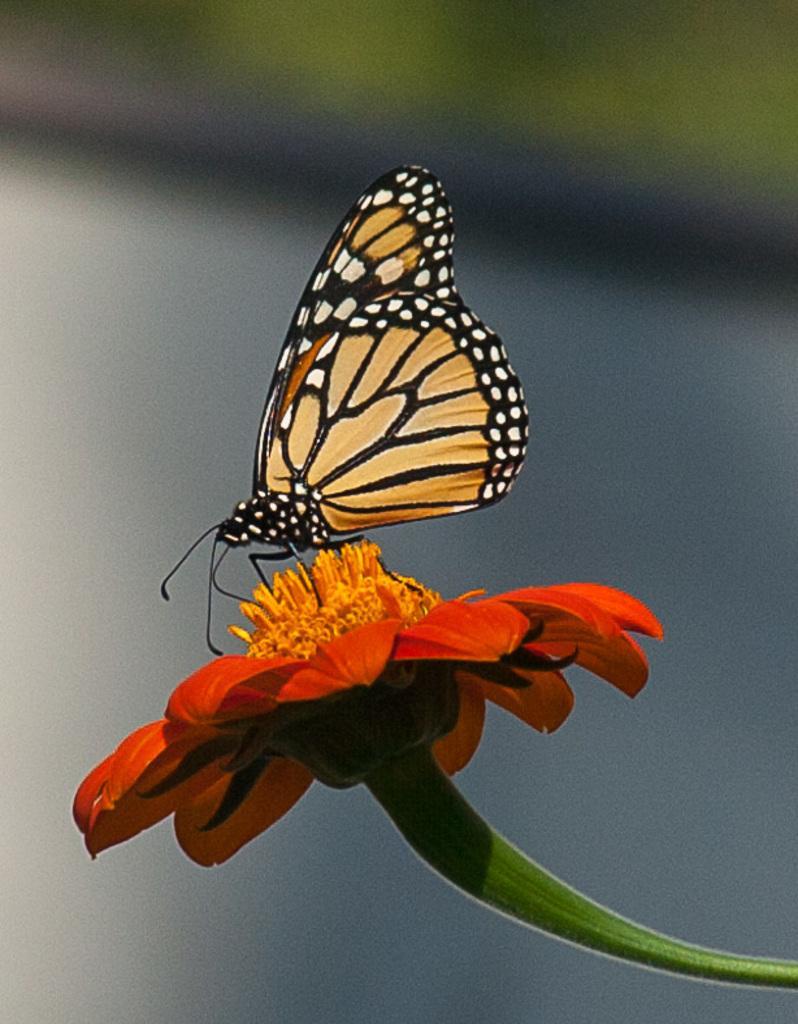Describe this image in one or two sentences. In this image we can see a butterfly on a flower, and the background is blurred. 